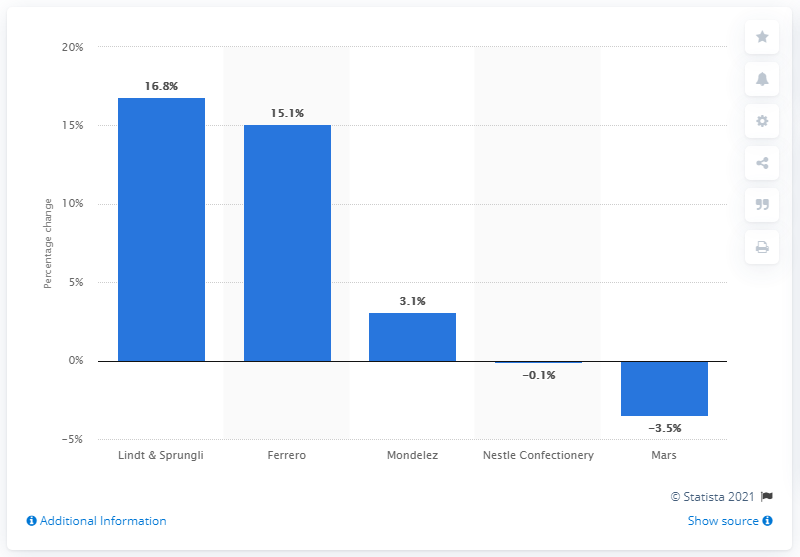Indicate a few pertinent items in this graphic. In 2016, Ferrero was the confectionery company with the highest revenue. 